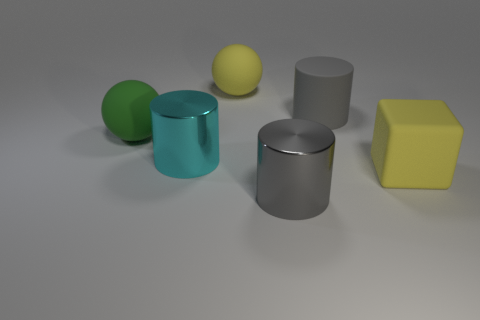How many things are either green metal spheres or large rubber objects that are behind the green object?
Keep it short and to the point. 2. Is there a gray metal object of the same shape as the cyan thing?
Give a very brief answer. Yes. Are there an equal number of gray metal things left of the green rubber object and big gray matte cylinders left of the large cyan shiny cylinder?
Make the answer very short. Yes. How many purple objects are either large matte cubes or big cylinders?
Provide a short and direct response. 0. What number of objects are the same size as the gray metallic cylinder?
Offer a terse response. 5. The big thing that is both to the right of the gray metal cylinder and to the left of the yellow matte cube is what color?
Your answer should be compact. Gray. Are there more large matte spheres behind the cyan metallic cylinder than tiny yellow matte objects?
Provide a short and direct response. Yes. Are there any tiny green metal spheres?
Offer a terse response. No. What number of big objects are either balls or gray shiny cylinders?
Make the answer very short. 3. Is there any other thing that is the same color as the matte cylinder?
Make the answer very short. Yes. 